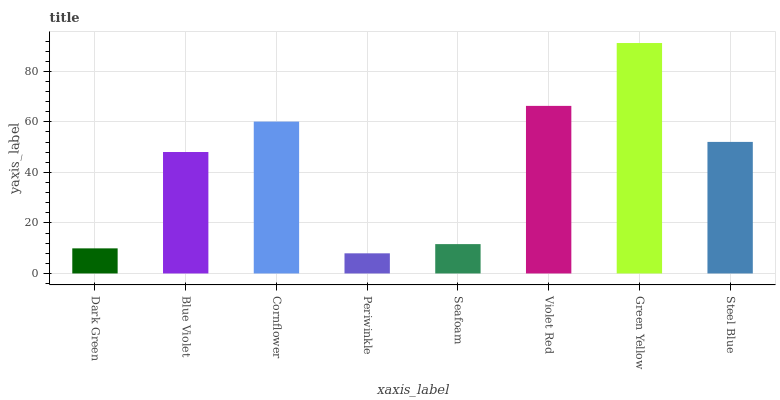Is Periwinkle the minimum?
Answer yes or no. Yes. Is Green Yellow the maximum?
Answer yes or no. Yes. Is Blue Violet the minimum?
Answer yes or no. No. Is Blue Violet the maximum?
Answer yes or no. No. Is Blue Violet greater than Dark Green?
Answer yes or no. Yes. Is Dark Green less than Blue Violet?
Answer yes or no. Yes. Is Dark Green greater than Blue Violet?
Answer yes or no. No. Is Blue Violet less than Dark Green?
Answer yes or no. No. Is Steel Blue the high median?
Answer yes or no. Yes. Is Blue Violet the low median?
Answer yes or no. Yes. Is Dark Green the high median?
Answer yes or no. No. Is Periwinkle the low median?
Answer yes or no. No. 